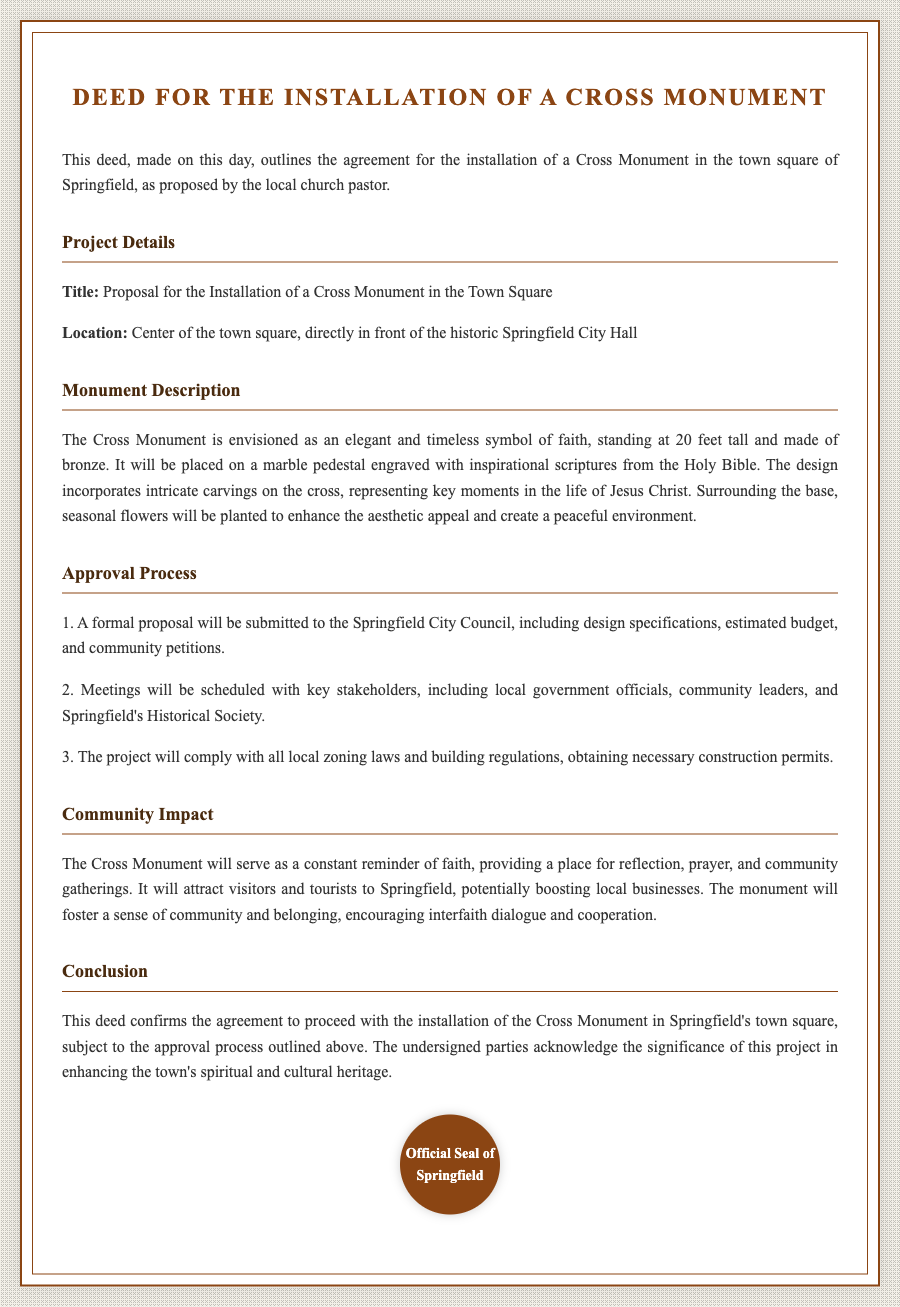what is the location of the Cross Monument? The location is specified as the center of the town square, directly in front of the historic Springfield City Hall.
Answer: Center of the town square how tall will the Cross Monument be? The height of the Cross Monument is explicitly stated as 20 feet tall.
Answer: 20 feet what material will the Cross Monument be made of? The document mentions that the Cross Monument will be made of bronze.
Answer: bronze who proposed the installation of the Cross Monument? The proposal is made by the local church pastor, as mentioned in the deed.
Answer: local church pastor what will surround the base of the Monument? The deed describes that seasonal flowers will be planted around the base of the Monument.
Answer: seasonal flowers what is the first step in the approval process? The first step involves submitting a formal proposal to the Springfield City Council, as detailed in the document.
Answer: submit a formal proposal what is one anticipated benefit of the Cross Monument for the community? One benefit mentioned is that the monument will attract visitors and tourists to Springfield.
Answer: attract visitors what is included in the monument's design? The design includes intricate carvings representing key moments in the life of Jesus Christ.
Answer: intricate carvings what signifies the project’s agreement? The deed confirms the agreement to proceed with the installation of the Cross Monument.
Answer: agreement to proceed 